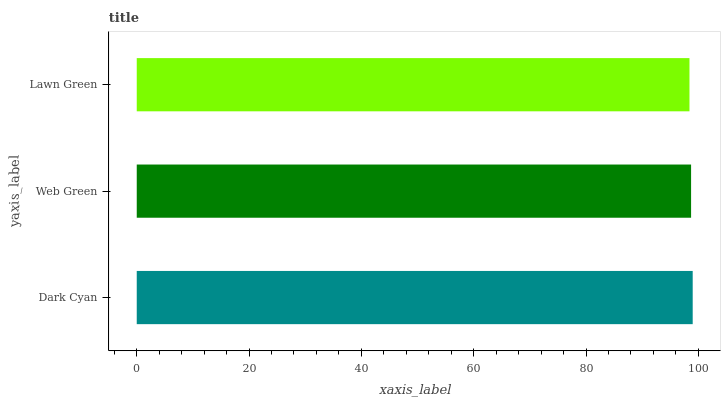Is Lawn Green the minimum?
Answer yes or no. Yes. Is Dark Cyan the maximum?
Answer yes or no. Yes. Is Web Green the minimum?
Answer yes or no. No. Is Web Green the maximum?
Answer yes or no. No. Is Dark Cyan greater than Web Green?
Answer yes or no. Yes. Is Web Green less than Dark Cyan?
Answer yes or no. Yes. Is Web Green greater than Dark Cyan?
Answer yes or no. No. Is Dark Cyan less than Web Green?
Answer yes or no. No. Is Web Green the high median?
Answer yes or no. Yes. Is Web Green the low median?
Answer yes or no. Yes. Is Dark Cyan the high median?
Answer yes or no. No. Is Lawn Green the low median?
Answer yes or no. No. 